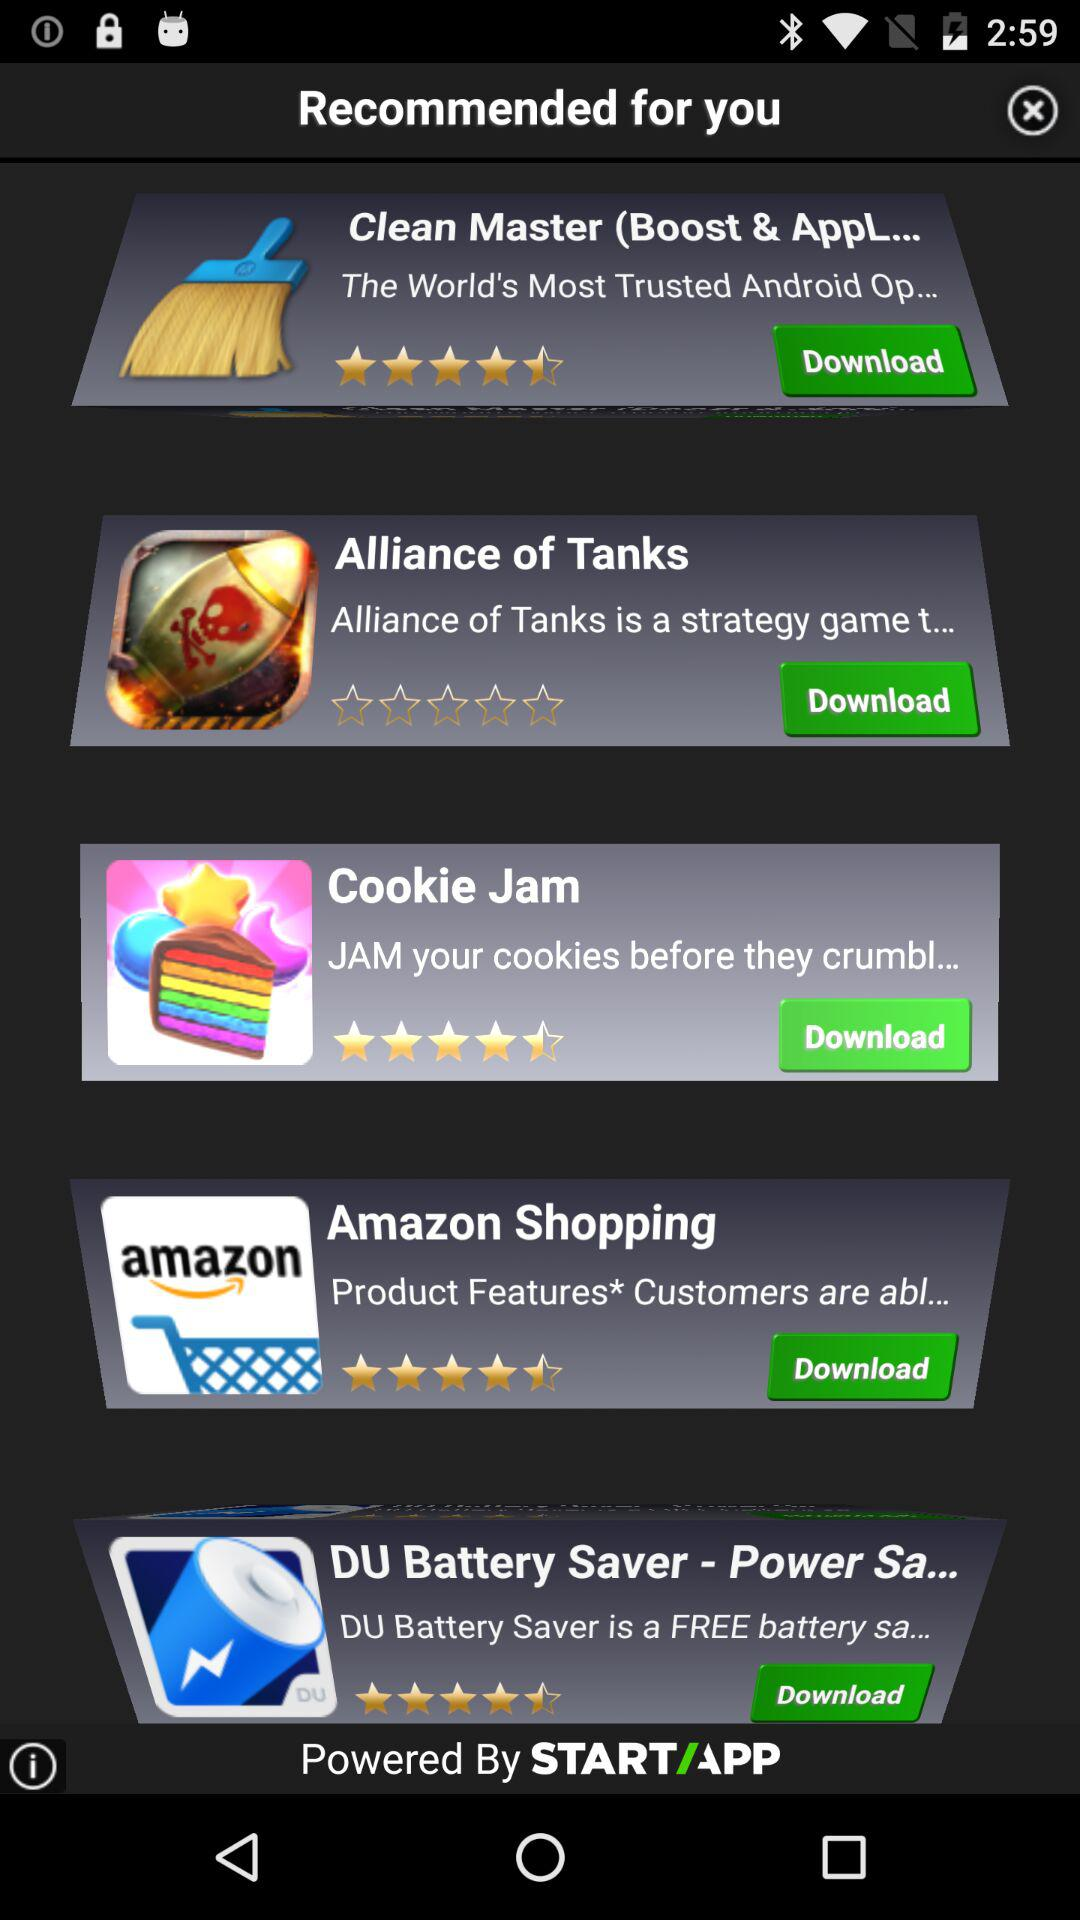What is the name of the application whose description is "The World's Most Trusted Android Op..."? The name of the application is "Clean Master (Boost & AppL...". 